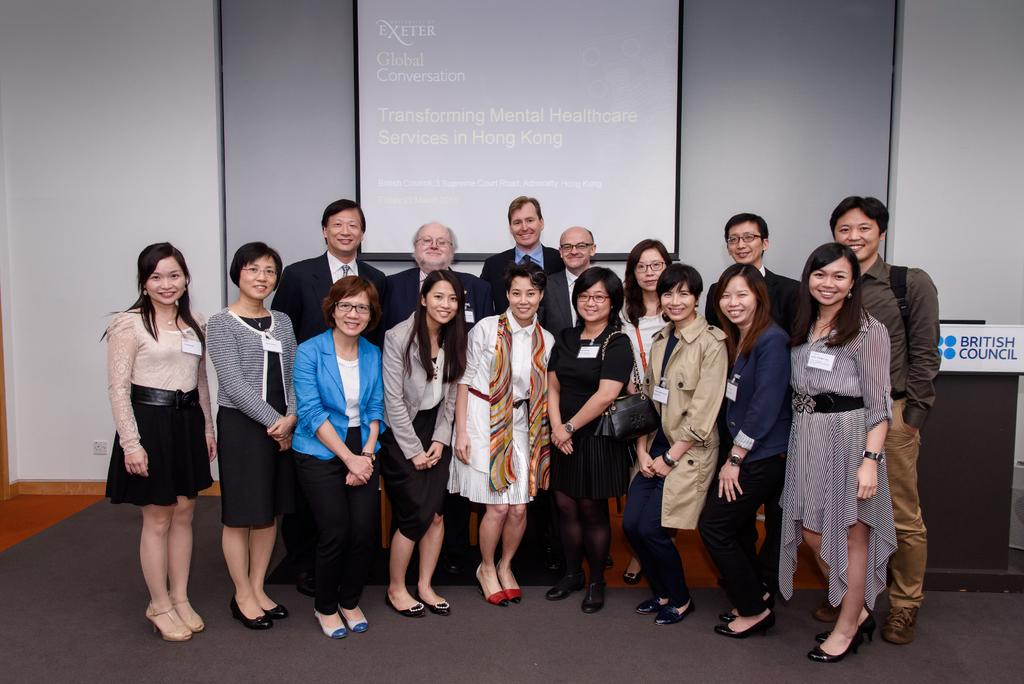How many people are in the image? There is a group of people in the image. What are the people standing on? The people are standing on a floor mat. What is behind the people? There is a wall behind the people. What is on the wall? The wall has a screen on it. What can be seen on the screen? There is some information displayed on the screen. What color is the sock that the person in the image is wearing? There is no mention of a sock or any clothing in the image, so we cannot determine the color of a sock. 